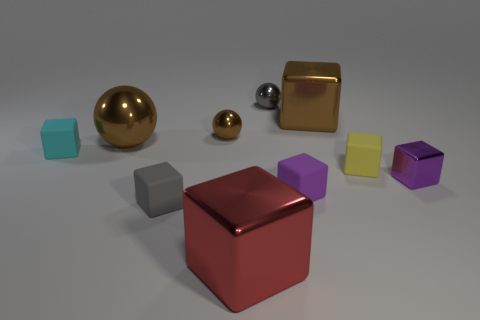Subtract 4 cubes. How many cubes are left? 3 Subtract all brown cubes. How many cubes are left? 6 Subtract all small metallic cubes. How many cubes are left? 6 Subtract all blue cubes. Subtract all purple spheres. How many cubes are left? 7 Subtract all cubes. How many objects are left? 3 Add 5 cyan matte blocks. How many cyan matte blocks exist? 6 Subtract 0 gray cylinders. How many objects are left? 10 Subtract all purple matte things. Subtract all purple matte blocks. How many objects are left? 8 Add 3 spheres. How many spheres are left? 6 